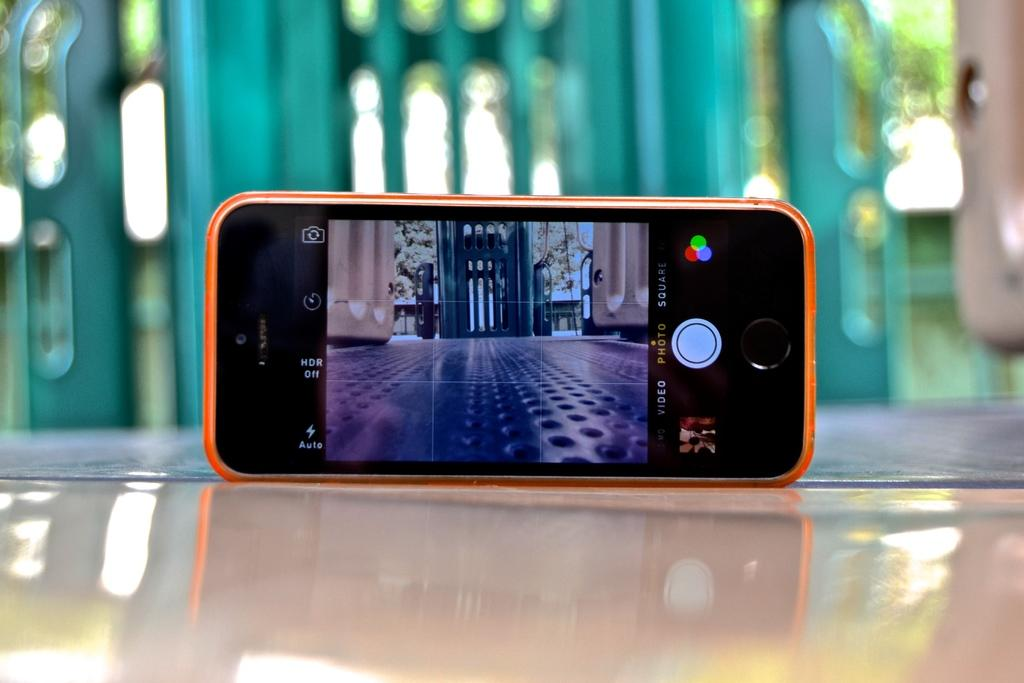Provide a one-sentence caption for the provided image. HDR off reads the setting of this camera phone. 